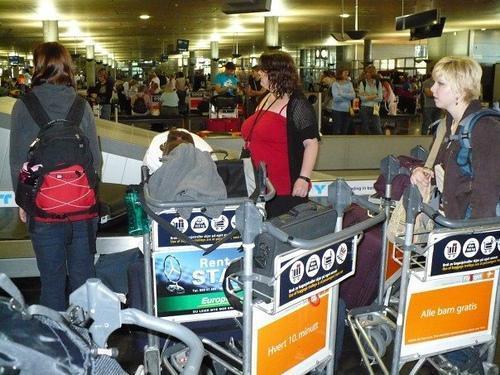How many people can you see?
Give a very brief answer. 4. How many suitcases can you see?
Give a very brief answer. 2. How many bottles are shown?
Give a very brief answer. 0. 